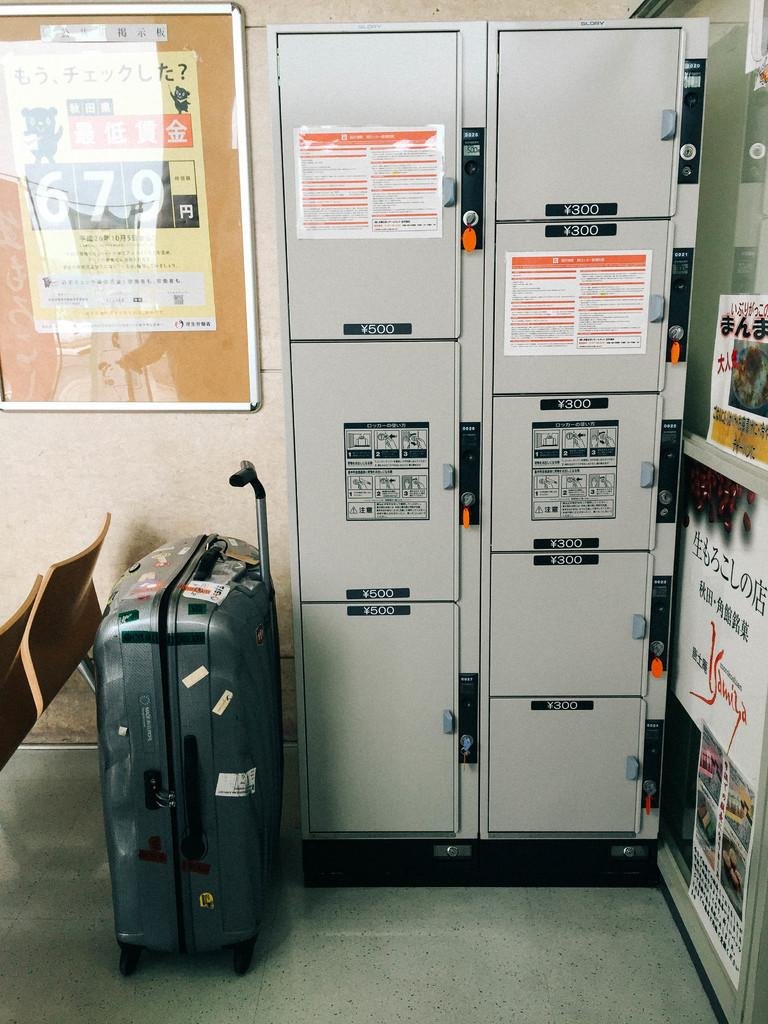What is located on the right side of the image? There is a power panel on the right side of the image. What is on the left side of the image? There is a trolley and chairs on the left side of the image. What type of plane can be seen flying in the image? There is no plane visible in the image; it only features a power panel and a trolley with chairs. What kind of steel is used to construct the chairs in the image? The image does not provide information about the type of steel used in the chairs, nor does it show any steel. 